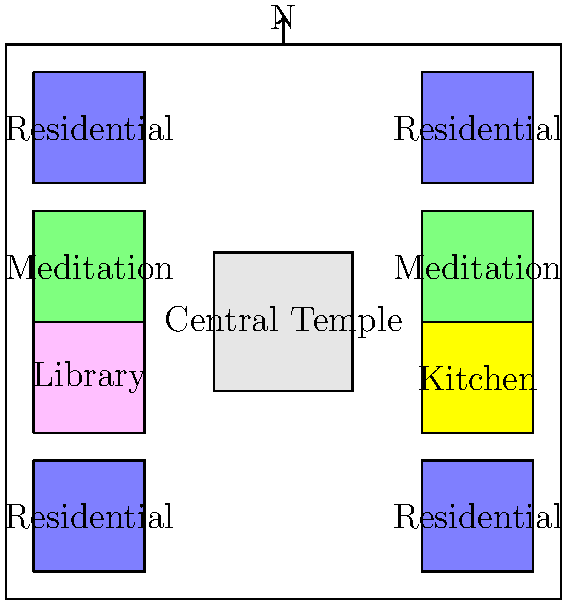Based on the architectural layout of this typical Buddhist monastery complex, which structure is positioned at the center, and how does this placement reflect the core principles of Buddhist philosophy? To answer this question, let's analyze the layout step-by-step:

1. Observe the central structure: The diagram shows a square building at the center of the complex.

2. Identify the central structure: This central building is labeled as the "Central Temple."

3. Surrounding structures: Around the central temple, we can see:
   - Four residential quarters in the corners
   - Two meditation halls on the sides
   - A library and a kitchen on opposite sides

4. Significance of central placement:
   a) In Buddhist architecture, the central position is reserved for the most important structure.
   b) The temple, being at the center, represents the Buddha and his teachings (Dharma).
   c) This central placement symbolizes the Buddha as the core of Buddhist practice and philosophy.

5. Reflection of Buddhist principles:
   a) Centrality: The temple's position reflects the central role of the Buddha and his teachings in monastic life.
   b) Balance: The symmetrical arrangement around the central temple represents harmony and equilibrium in Buddhist practice.
   c) Focus: All other structures face or surround the central temple, indicating that all activities revolve around Buddhist teachings and practices.
   d) Hierarchy: The central placement establishes a spiritual hierarchy, with the Buddha's teachings at the apex.

6. Practical aspects:
   a) Accessibility: The central location allows easy access from all parts of the monastery.
   b) Visibility: The temple serves as a constant visual reminder of the spiritual purpose of monastic life.

Thus, the central placement of the temple reflects core Buddhist principles of centrality of the Buddha's teachings, balance, focus, and spiritual hierarchy in monastic life.
Answer: Central Temple; symbolizes Buddha and Dharma as core of Buddhist practice 